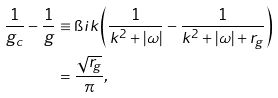<formula> <loc_0><loc_0><loc_500><loc_500>\frac { 1 } { g _ { c } } - \frac { 1 } { g } & \equiv \i i k \left ( \frac { 1 } { k ^ { 2 } + | \omega | } - \frac { 1 } { k ^ { 2 } + | \omega | + r _ { g } } \right ) \\ & = \frac { \sqrt { r _ { g } } } { \pi } ,</formula> 